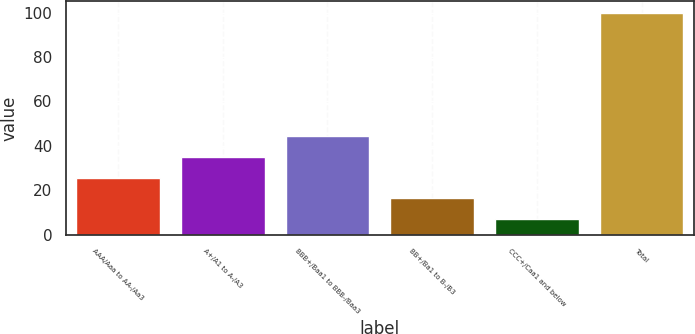<chart> <loc_0><loc_0><loc_500><loc_500><bar_chart><fcel>AAA/Aaa to AA-/Aa3<fcel>A+/A1 to A-/A3<fcel>BBB+/Baa1 to BBB-/Baa3<fcel>BB+/Ba1 to B-/B3<fcel>CCC+/Caa1 and below<fcel>Total<nl><fcel>25.6<fcel>34.9<fcel>44.2<fcel>16.3<fcel>7<fcel>100<nl></chart> 